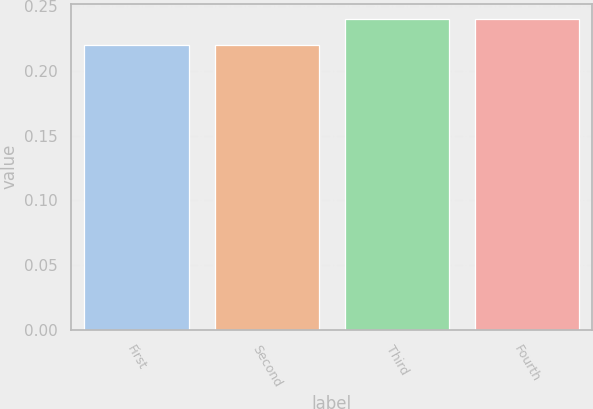Convert chart. <chart><loc_0><loc_0><loc_500><loc_500><bar_chart><fcel>First<fcel>Second<fcel>Third<fcel>Fourth<nl><fcel>0.22<fcel>0.22<fcel>0.24<fcel>0.24<nl></chart> 